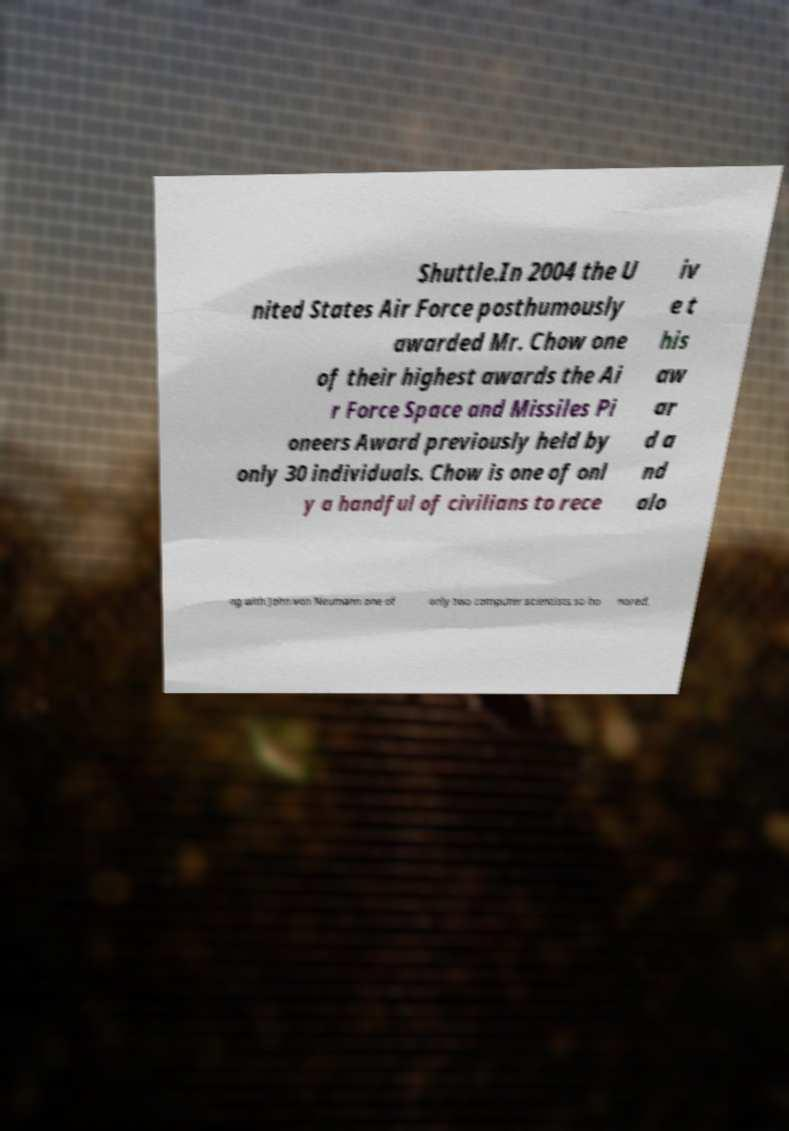I need the written content from this picture converted into text. Can you do that? Shuttle.In 2004 the U nited States Air Force posthumously awarded Mr. Chow one of their highest awards the Ai r Force Space and Missiles Pi oneers Award previously held by only 30 individuals. Chow is one of onl y a handful of civilians to rece iv e t his aw ar d a nd alo ng with John von Neumann one of only two computer scientists so ho nored. 